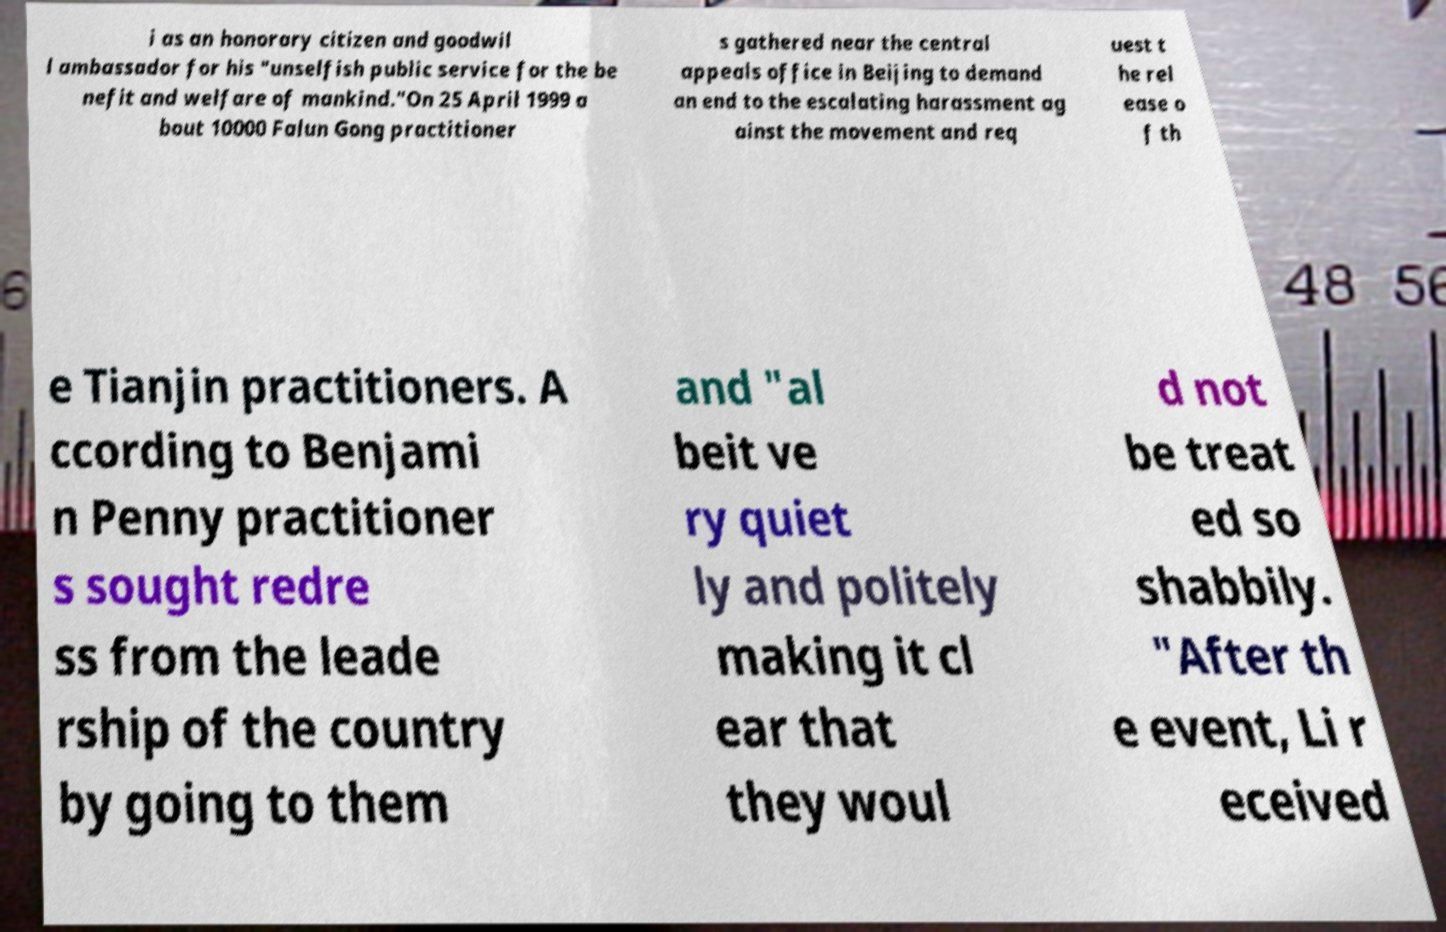I need the written content from this picture converted into text. Can you do that? i as an honorary citizen and goodwil l ambassador for his "unselfish public service for the be nefit and welfare of mankind."On 25 April 1999 a bout 10000 Falun Gong practitioner s gathered near the central appeals office in Beijing to demand an end to the escalating harassment ag ainst the movement and req uest t he rel ease o f th e Tianjin practitioners. A ccording to Benjami n Penny practitioner s sought redre ss from the leade rship of the country by going to them and "al beit ve ry quiet ly and politely making it cl ear that they woul d not be treat ed so shabbily. "After th e event, Li r eceived 